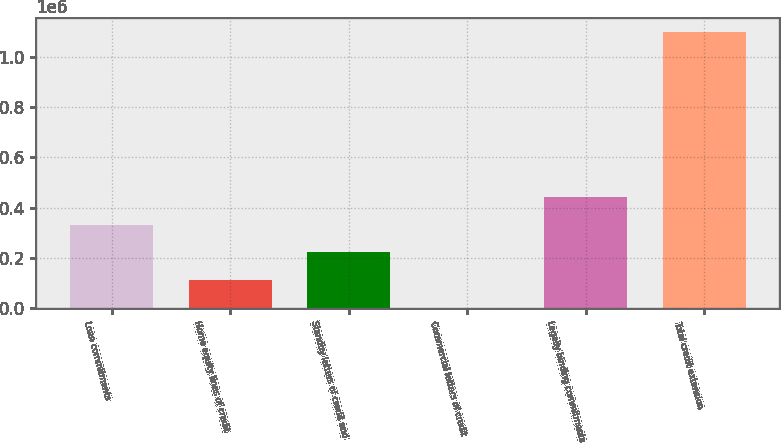<chart> <loc_0><loc_0><loc_500><loc_500><bar_chart><fcel>Loan commitments<fcel>Home equity lines of credit<fcel>Standby letters of credit and<fcel>Commercial letters of credit<fcel>Legally binding commitments<fcel>Total credit extension<nl><fcel>332384<fcel>113296<fcel>222840<fcel>3753<fcel>441927<fcel>1.09919e+06<nl></chart> 